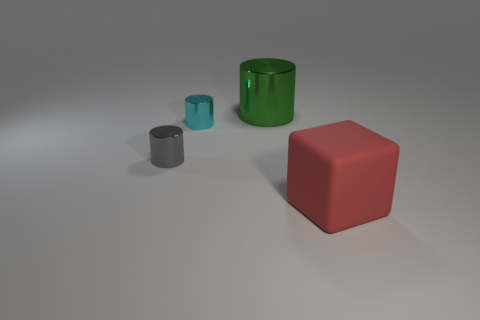Are there any big cyan matte cylinders? Indeed, there is one large cyan matte cylinder in the image, placed between the small grey cylinder and the red cube. 